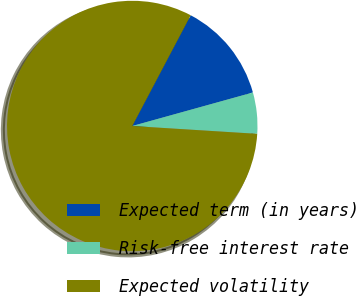<chart> <loc_0><loc_0><loc_500><loc_500><pie_chart><fcel>Expected term (in years)<fcel>Risk-free interest rate<fcel>Expected volatility<nl><fcel>12.96%<fcel>5.31%<fcel>81.73%<nl></chart> 